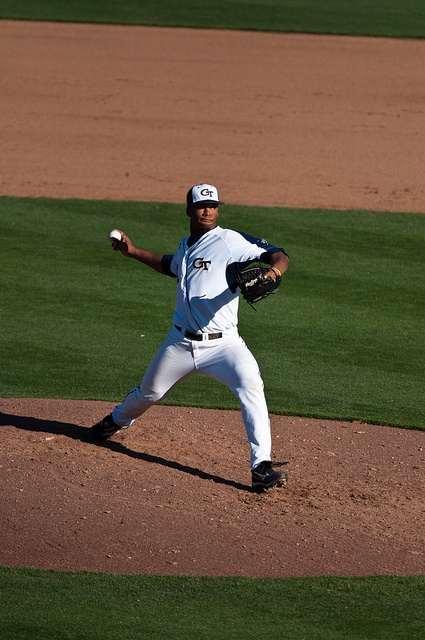Describe the objects in this image and their specific colors. I can see people in darkgreen, lavender, black, darkblue, and darkgray tones, baseball glove in darkgreen, black, and gray tones, and sports ball in darkgreen, white, black, gray, and darkgray tones in this image. 